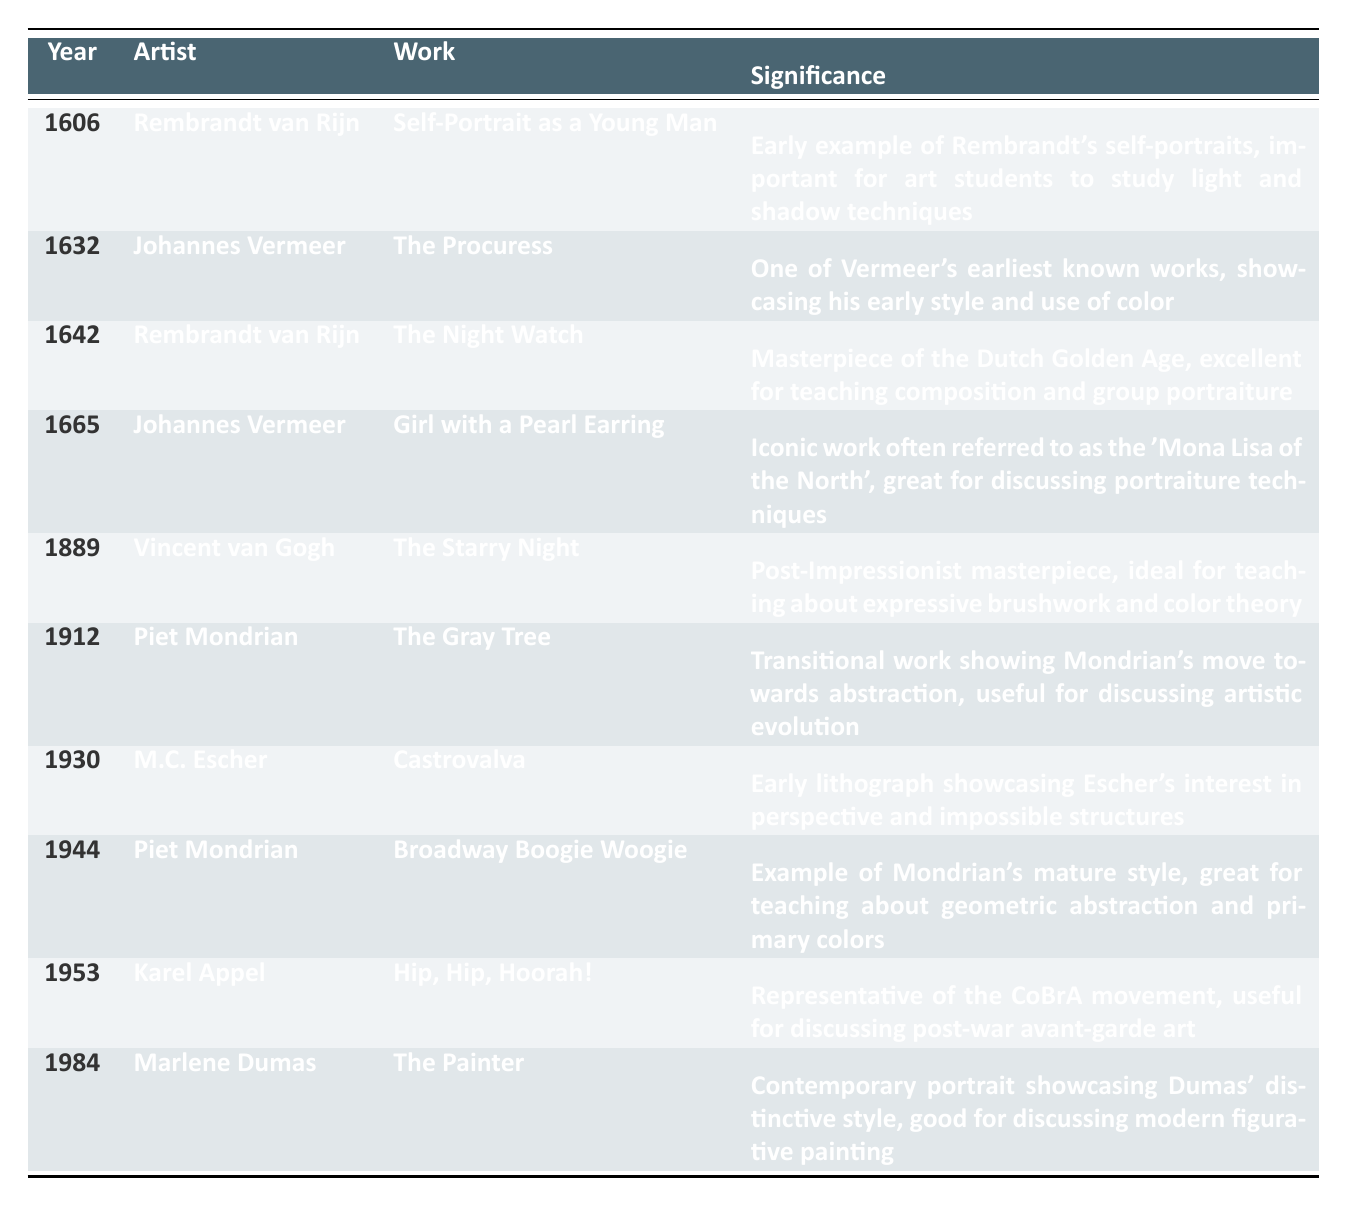What significant work did Rembrandt van Rijn create in 1642? The table lists "The Night Watch" as the significant work created by Rembrandt van Rijn in 1642.
Answer: The Night Watch Which artist is known for the work titled "Girl with a Pearl Earring"? According to the table, "Girl with a Pearl Earring" is the work of Johannes Vermeer.
Answer: Johannes Vermeer Is "The Painter" by Marlene Dumas part of the timeline? Yes, the table clearly indicates that "The Painter" is a work by Marlene Dumas created in 1984.
Answer: Yes What year was "The Starry Night" created, and who is the artist? From the table, "The Starry Night" was created by Vincent van Gogh in 1889.
Answer: 1889, Vincent van Gogh How many works by Piet Mondrian are listed in the timeline? The table shows two works by Piet Mondrian: "The Gray Tree" (1912) and "Broadway Boogie Woogie" (1944). Thus, there are two works mentioned.
Answer: 2 Which artist's work serves as an early example for discussing expressive brushwork and color theory? The table indicates that Vincent van Gogh's "The Starry Night" is noted for its expressive brushwork and color theory, making it ideal for teaching.
Answer: Vincent van Gogh What is the significance of "Castrovalva" by M.C. Escher? The table states that "Castrovalva" showcases Escher's interest in perspective and impossible structures, highlighting its significance in early lithography.
Answer: Interest in perspective and impossible structures Which artist's works are primarily associated with the Dutch Golden Age? The table identifies Rembrandt van Rijn and Johannes Vermeer as artists whose works, including "The Night Watch" and "Girl with a Pearl Earring," are significant to the Dutch Golden Age.
Answer: Rembrandt van Rijn and Johannes Vermeer What artistic style is exemplified in "Broadway Boogie Woogie"? The table outlines that "Broadway Boogie Woogie" reflects Piet Mondrian's mature style, particularly in geometric abstraction and primary colors.
Answer: Geometric abstraction and primary colors Is Marlene Dumas's "The Painter" the only contemporary piece listed in the timeline? Yes, the table shows that "The Painter," created in 1984 by Marlene Dumas, is the sole contemporary piece indicated, making it the only one on the list.
Answer: Yes 